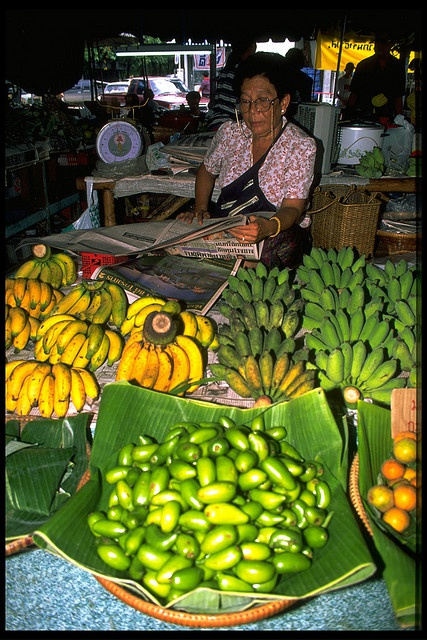Describe the objects in this image and their specific colors. I can see people in black, maroon, and gray tones, banana in black, olive, darkgreen, and khaki tones, banana in black, orange, gold, and olive tones, banana in black and darkgreen tones, and banana in black, gold, orange, and olive tones in this image. 